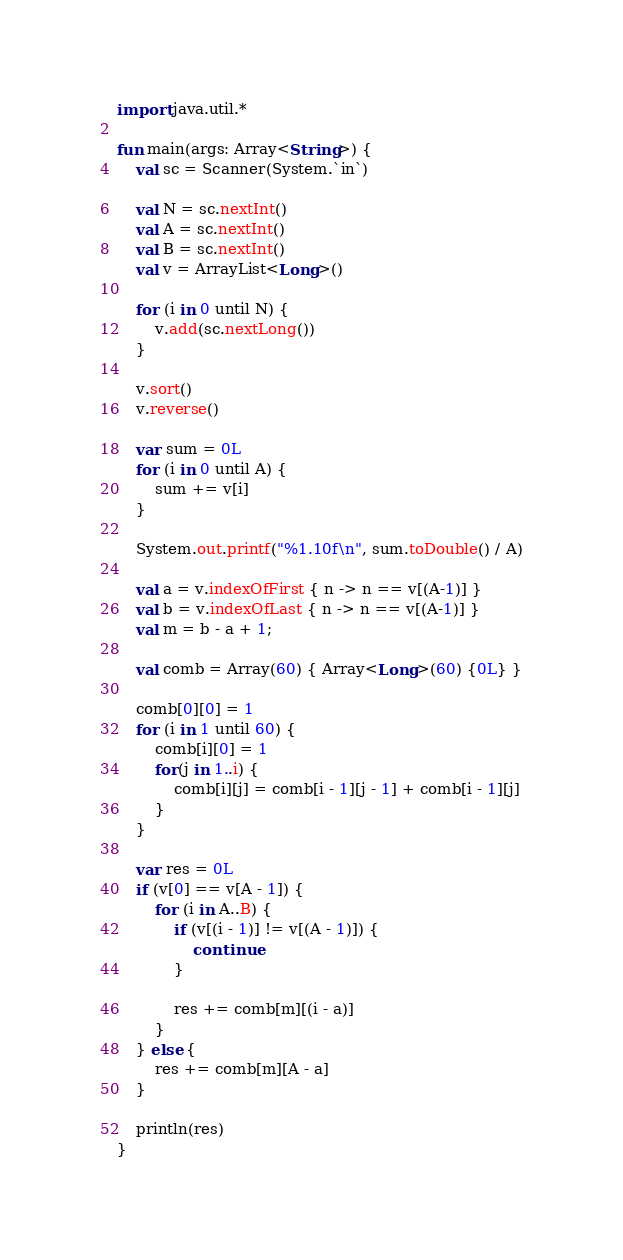<code> <loc_0><loc_0><loc_500><loc_500><_Kotlin_>import java.util.*

fun main(args: Array<String>) {
    val sc = Scanner(System.`in`)

    val N = sc.nextInt()
    val A = sc.nextInt()
    val B = sc.nextInt()
    val v = ArrayList<Long>()

    for (i in 0 until N) {
        v.add(sc.nextLong())
    }

    v.sort()
    v.reverse()

    var sum = 0L
    for (i in 0 until A) {
        sum += v[i]
    }

    System.out.printf("%1.10f\n", sum.toDouble() / A)

    val a = v.indexOfFirst { n -> n == v[(A-1)] }
    val b = v.indexOfLast { n -> n == v[(A-1)] }
    val m = b - a + 1;

    val comb = Array(60) { Array<Long>(60) {0L} }

    comb[0][0] = 1
    for (i in 1 until 60) {
        comb[i][0] = 1
        for(j in 1..i) {
            comb[i][j] = comb[i - 1][j - 1] + comb[i - 1][j]
        }
    }

    var res = 0L
    if (v[0] == v[A - 1]) {
        for (i in A..B) {
            if (v[(i - 1)] != v[(A - 1)]) {
                continue
            }

            res += comb[m][(i - a)]
        }
    } else {
        res += comb[m][A - a]
    }

    println(res)
}</code> 